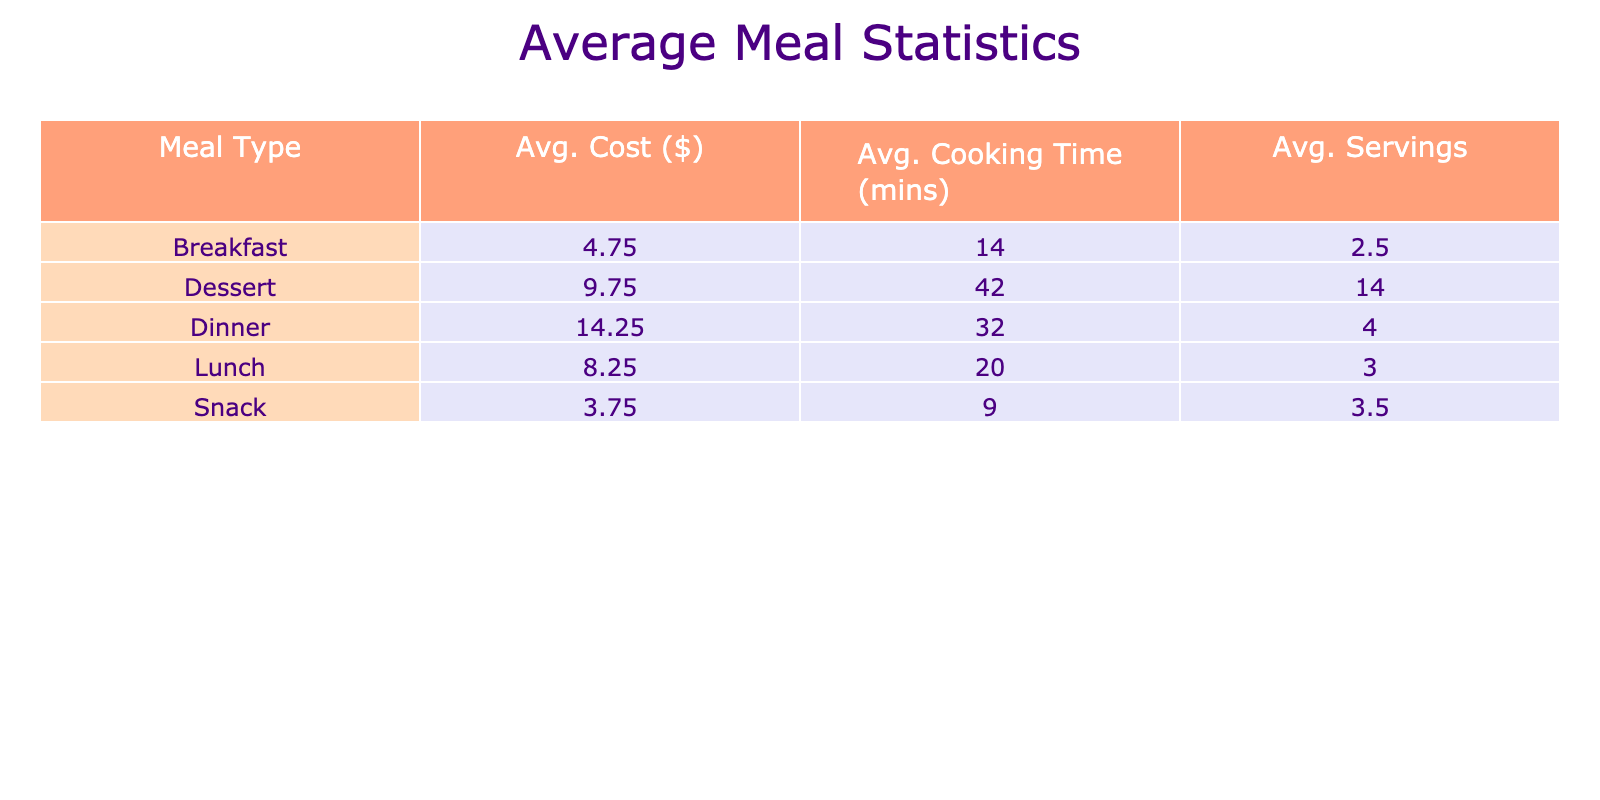What is the average cost of breakfast meals? To find the average cost of breakfast meals, we look at the "Cost ($)" for each breakfast entry: 5, 7, 4, and 3. The sum of these costs is 5 + 7 + 4 + 3 = 19. There are 4 breakfast meals, so the average cost is 19 / 4 = 4.75.
Answer: 4.75 Which meal type has the highest average cooking time? Reviewing the average cooking times for each meal type, we see Breakfast averages 12.5 mins, Lunch averages 15 mins, Dinner averages 27.5 mins, Snack averages 5 mins, and Dessert averages 34.5 mins. The highest average cooking time is 34.5 mins for Dessert.
Answer: Dessert Is the average cost of lunch meals greater than $10? The average costs for lunch meals are 15, 3, 10, and 10, giving a total of 38. Dividing by the number of lunch meals (4), the average cost is 9.5. Since 9.5 is not greater than 10, the answer is no.
Answer: No What is the average number of servings for dinner meals? The number of servings for dinner meals are 4, 4, 4, and 4, totaling to 16. There are 4 dinner meals, so the average is 16 / 4 = 4.
Answer: 4 Which meal type has the lowest average cost? The average costs for each meal type are as follows: Breakfast is 4.75, Lunch is 9.5, Dinner is 15, Snack is 4, and Dessert is 20. The lowest average cost is for Breakfast at 4.75.
Answer: Breakfast What is the total cost for all meals across all weeks? To find the total cost, sum all the individual meal costs: 5 + 15 + 10 + 4 + 6 + 7 + 3 + 12 + 5 + 8 + 4 + 20 + 4 + 10 + 15 + 2 + 10 =  10 + 8 + 38 = 103. The total cost for all meals across all weeks is 103.
Answer: 103 